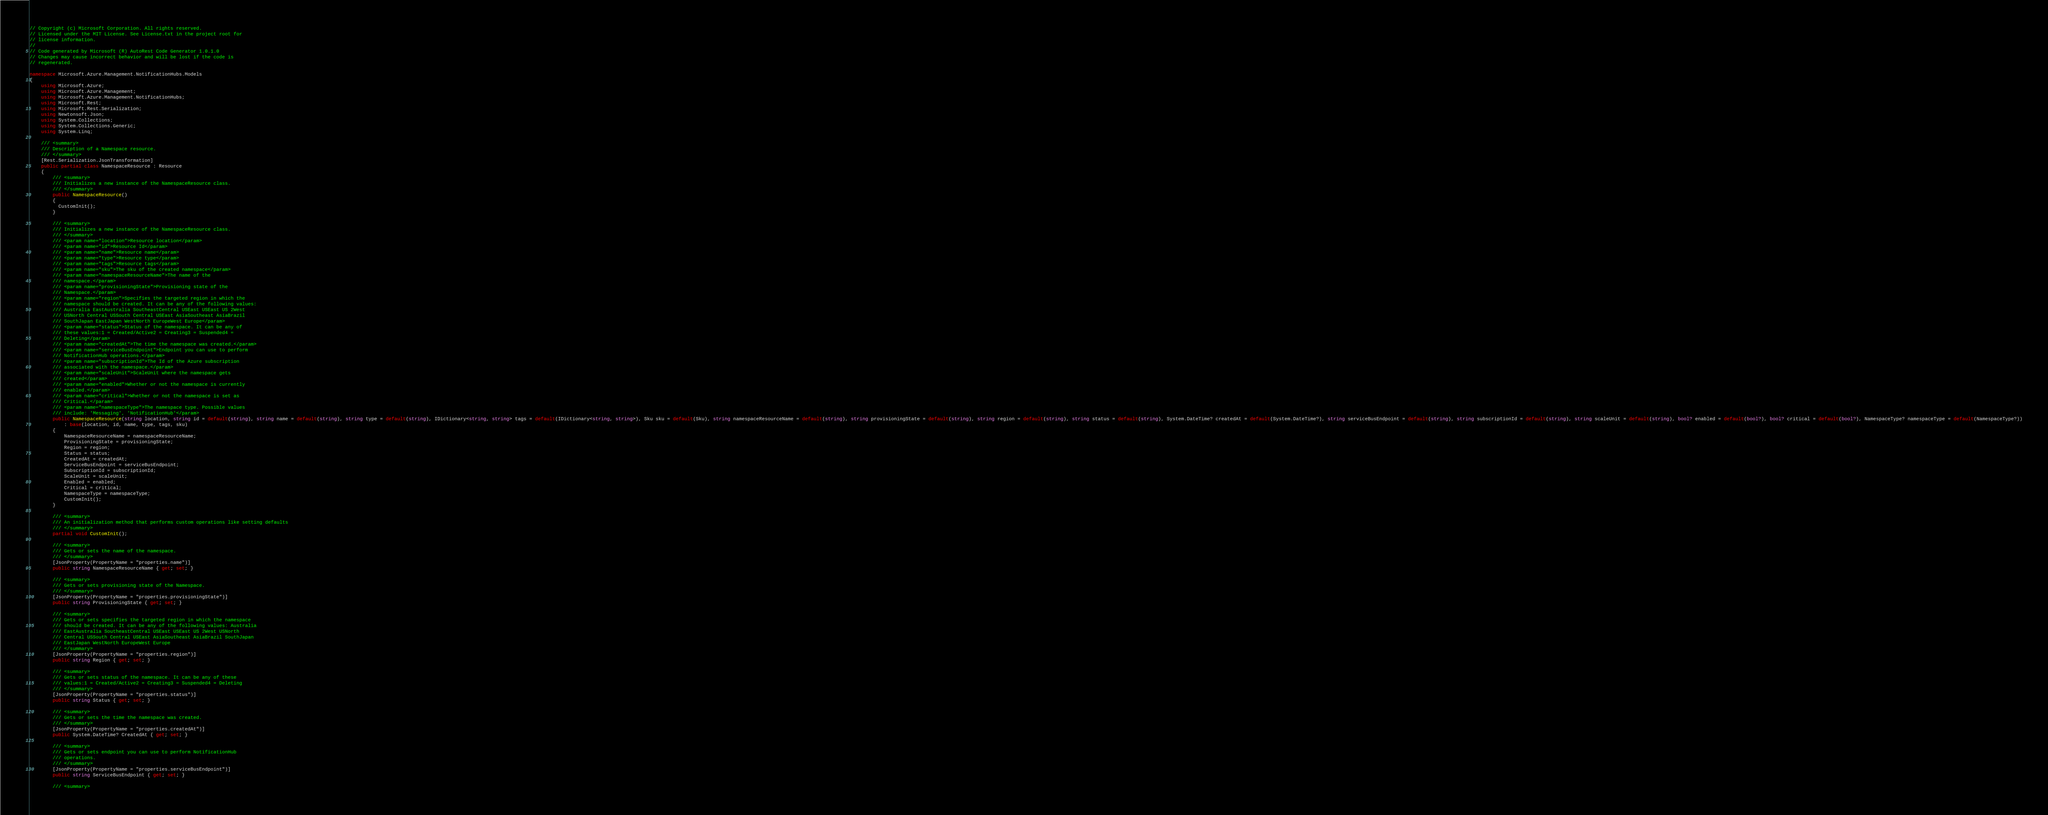<code> <loc_0><loc_0><loc_500><loc_500><_C#_>// Copyright (c) Microsoft Corporation. All rights reserved.
// Licensed under the MIT License. See License.txt in the project root for
// license information.
//
// Code generated by Microsoft (R) AutoRest Code Generator 1.0.1.0
// Changes may cause incorrect behavior and will be lost if the code is
// regenerated.

namespace Microsoft.Azure.Management.NotificationHubs.Models
{
    using Microsoft.Azure;
    using Microsoft.Azure.Management;
    using Microsoft.Azure.Management.NotificationHubs;
    using Microsoft.Rest;
    using Microsoft.Rest.Serialization;
    using Newtonsoft.Json;
    using System.Collections;
    using System.Collections.Generic;
    using System.Linq;

    /// <summary>
    /// Description of a Namespace resource.
    /// </summary>
    [Rest.Serialization.JsonTransformation]
    public partial class NamespaceResource : Resource
    {
        /// <summary>
        /// Initializes a new instance of the NamespaceResource class.
        /// </summary>
        public NamespaceResource()
        {
          CustomInit();
        }

        /// <summary>
        /// Initializes a new instance of the NamespaceResource class.
        /// </summary>
        /// <param name="location">Resource location</param>
        /// <param name="id">Resource Id</param>
        /// <param name="name">Resource name</param>
        /// <param name="type">Resource type</param>
        /// <param name="tags">Resource tags</param>
        /// <param name="sku">The sku of the created namespace</param>
        /// <param name="namespaceResourceName">The name of the
        /// namespace.</param>
        /// <param name="provisioningState">Provisioning state of the
        /// Namespace.</param>
        /// <param name="region">Specifies the targeted region in which the
        /// namespace should be created. It can be any of the following values:
        /// Australia EastAustralia SoutheastCentral USEast USEast US 2West
        /// USNorth Central USSouth Central USEast AsiaSoutheast AsiaBrazil
        /// SouthJapan EastJapan WestNorth EuropeWest Europe</param>
        /// <param name="status">Status of the namespace. It can be any of
        /// these values:1 = Created/Active2 = Creating3 = Suspended4 =
        /// Deleting</param>
        /// <param name="createdAt">The time the namespace was created.</param>
        /// <param name="serviceBusEndpoint">Endpoint you can use to perform
        /// NotificationHub operations.</param>
        /// <param name="subscriptionId">The Id of the Azure subscription
        /// associated with the namespace.</param>
        /// <param name="scaleUnit">ScaleUnit where the namespace gets
        /// created</param>
        /// <param name="enabled">Whether or not the namespace is currently
        /// enabled.</param>
        /// <param name="critical">Whether or not the namespace is set as
        /// Critical.</param>
        /// <param name="namespaceType">The namespace type. Possible values
        /// include: 'Messaging', 'NotificationHub'</param>
        public NamespaceResource(string location, string id = default(string), string name = default(string), string type = default(string), IDictionary<string, string> tags = default(IDictionary<string, string>), Sku sku = default(Sku), string namespaceResourceName = default(string), string provisioningState = default(string), string region = default(string), string status = default(string), System.DateTime? createdAt = default(System.DateTime?), string serviceBusEndpoint = default(string), string subscriptionId = default(string), string scaleUnit = default(string), bool? enabled = default(bool?), bool? critical = default(bool?), NamespaceType? namespaceType = default(NamespaceType?))
            : base(location, id, name, type, tags, sku)
        {
            NamespaceResourceName = namespaceResourceName;
            ProvisioningState = provisioningState;
            Region = region;
            Status = status;
            CreatedAt = createdAt;
            ServiceBusEndpoint = serviceBusEndpoint;
            SubscriptionId = subscriptionId;
            ScaleUnit = scaleUnit;
            Enabled = enabled;
            Critical = critical;
            NamespaceType = namespaceType;
            CustomInit();
        }

        /// <summary>
        /// An initialization method that performs custom operations like setting defaults
        /// </summary>
        partial void CustomInit();

        /// <summary>
        /// Gets or sets the name of the namespace.
        /// </summary>
        [JsonProperty(PropertyName = "properties.name")]
        public string NamespaceResourceName { get; set; }

        /// <summary>
        /// Gets or sets provisioning state of the Namespace.
        /// </summary>
        [JsonProperty(PropertyName = "properties.provisioningState")]
        public string ProvisioningState { get; set; }

        /// <summary>
        /// Gets or sets specifies the targeted region in which the namespace
        /// should be created. It can be any of the following values: Australia
        /// EastAustralia SoutheastCentral USEast USEast US 2West USNorth
        /// Central USSouth Central USEast AsiaSoutheast AsiaBrazil SouthJapan
        /// EastJapan WestNorth EuropeWest Europe
        /// </summary>
        [JsonProperty(PropertyName = "properties.region")]
        public string Region { get; set; }

        /// <summary>
        /// Gets or sets status of the namespace. It can be any of these
        /// values:1 = Created/Active2 = Creating3 = Suspended4 = Deleting
        /// </summary>
        [JsonProperty(PropertyName = "properties.status")]
        public string Status { get; set; }

        /// <summary>
        /// Gets or sets the time the namespace was created.
        /// </summary>
        [JsonProperty(PropertyName = "properties.createdAt")]
        public System.DateTime? CreatedAt { get; set; }

        /// <summary>
        /// Gets or sets endpoint you can use to perform NotificationHub
        /// operations.
        /// </summary>
        [JsonProperty(PropertyName = "properties.serviceBusEndpoint")]
        public string ServiceBusEndpoint { get; set; }

        /// <summary></code> 